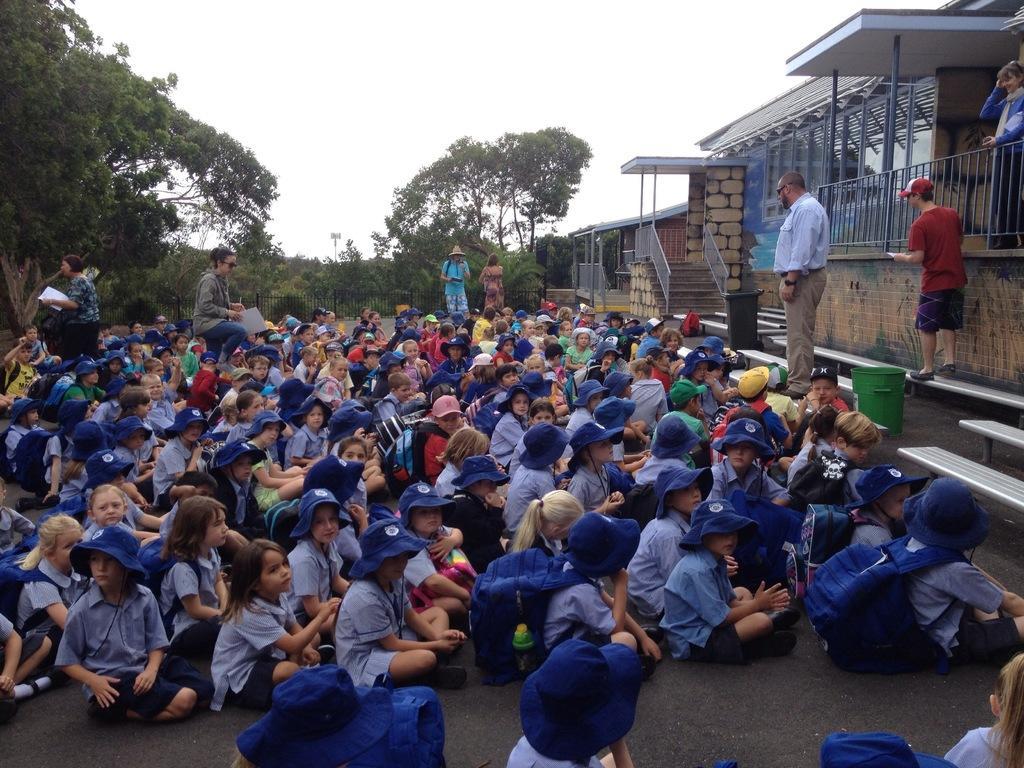Can you describe this image briefly? In this image there are so many children sitting on the road, in front of them there is a building, dustbin and some people are standing also there are so many trees behind them. 